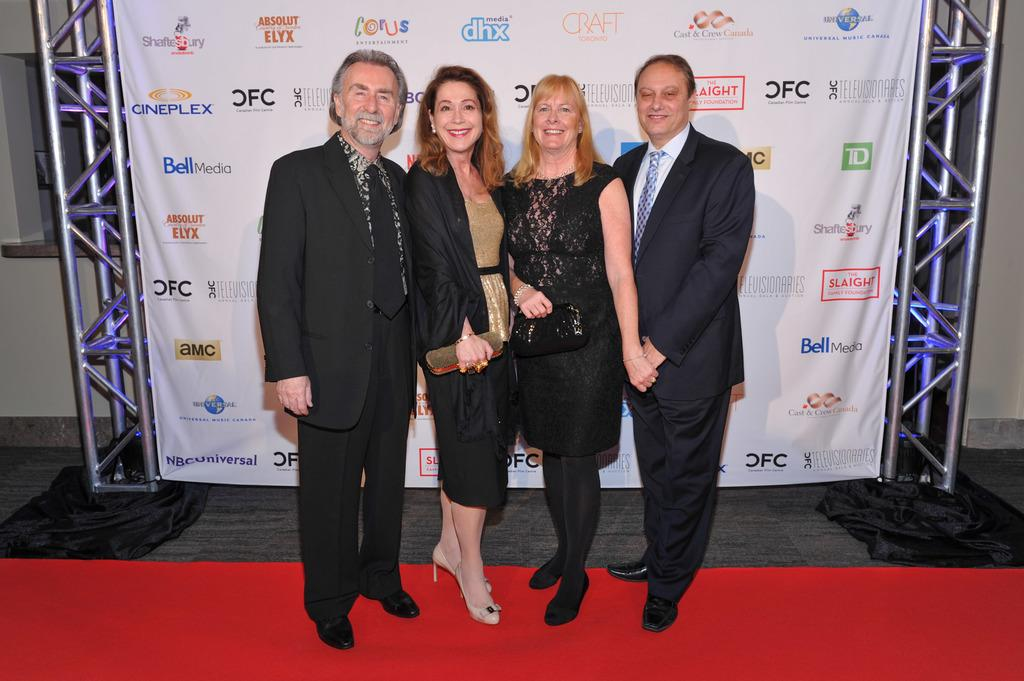What is happening in the image? There are people standing on a red carpet in the image. What else can be seen in the image? There is a banner visible in the image. How is the banner supported? The banner is attached to iron poles. What type of plough is being used on the sidewalk in the image? There is no plough present in the image; it features people standing on a red carpet and a banner attached to iron poles. How does the stomach of the person on the left feel in the image? There is no information about the person's stomach in the image, as it only shows people standing on a red carpet and a banner attached to iron poles. 